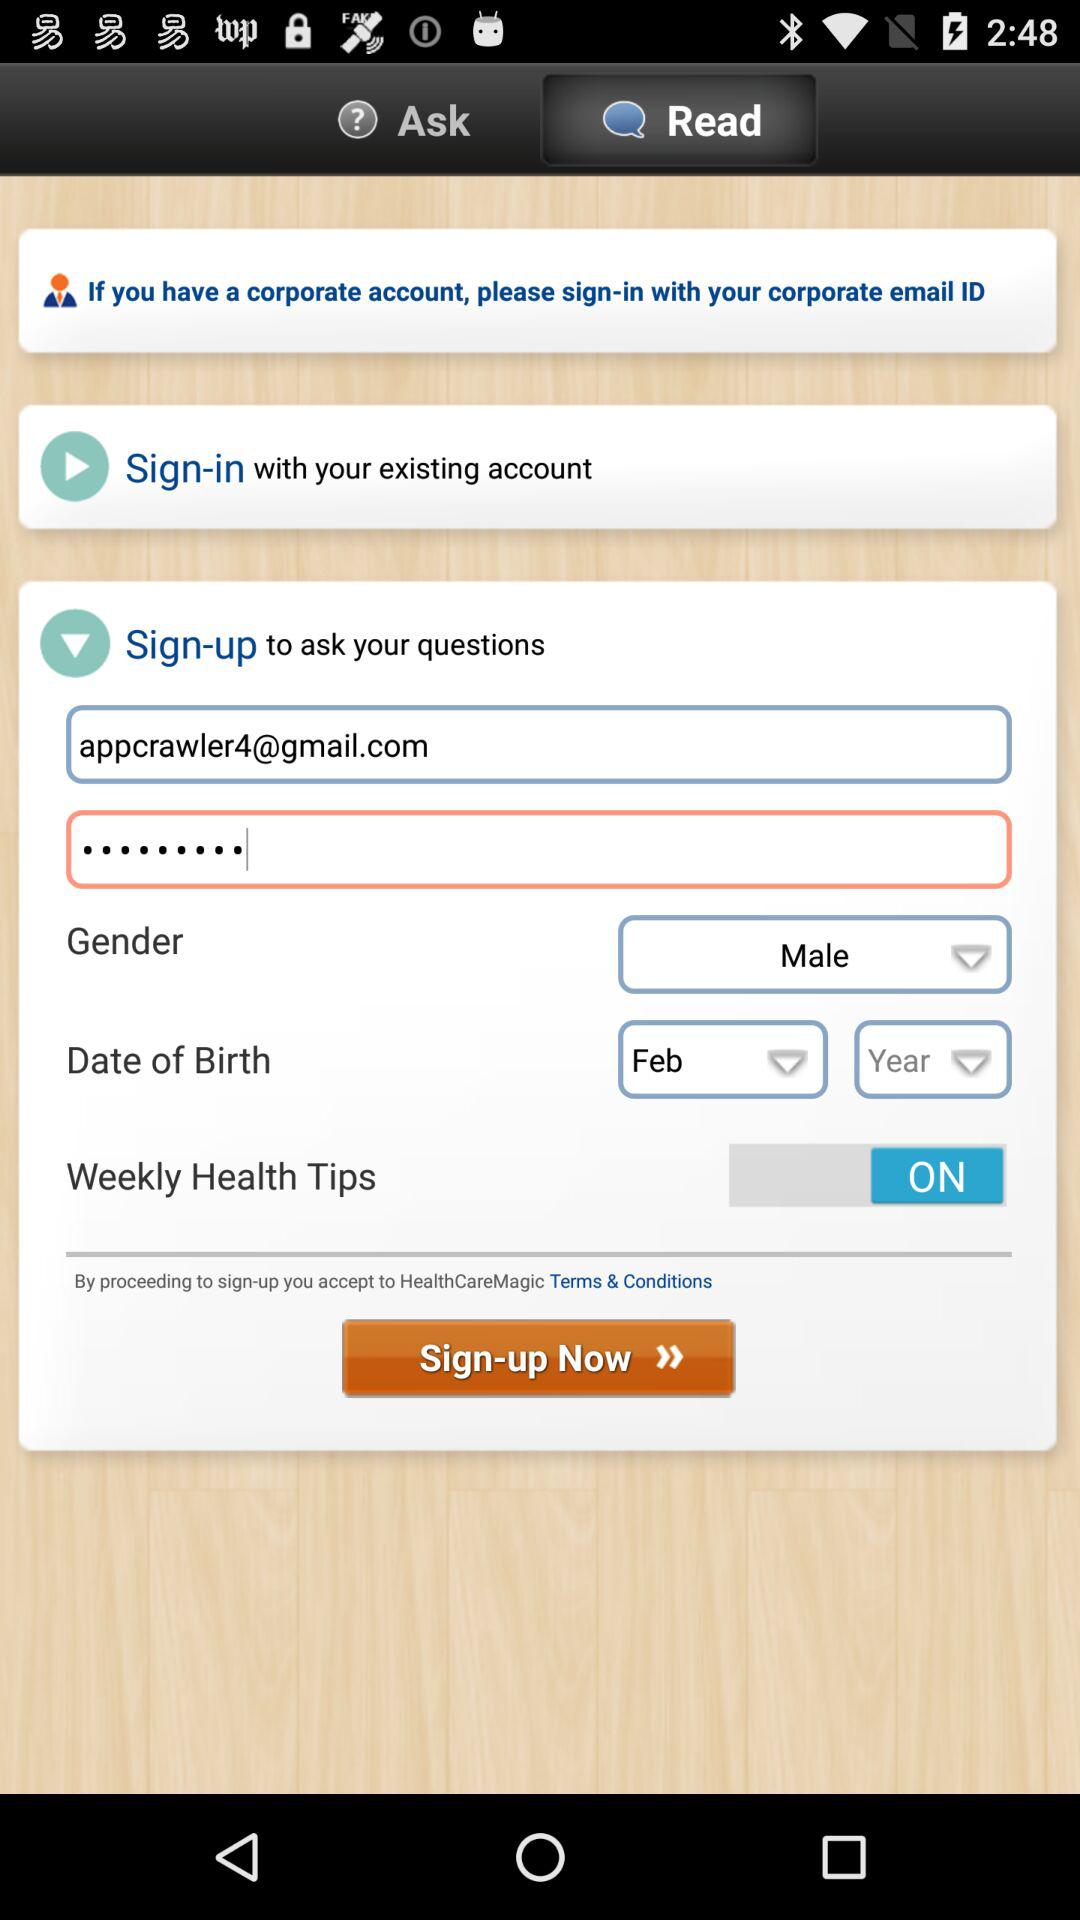What is the email address? The email address is appcrawler4@gmail.com. 